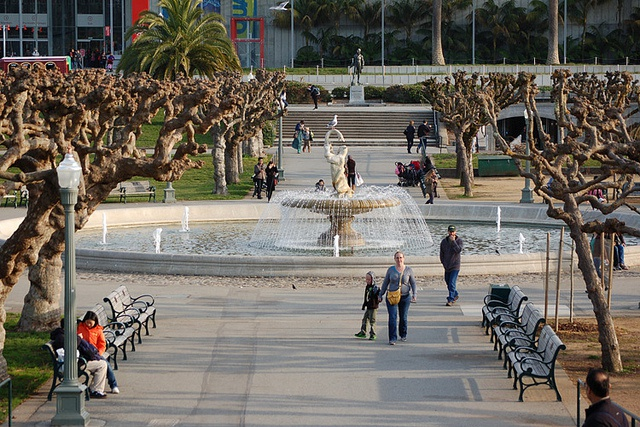Describe the objects in this image and their specific colors. I can see people in black, gray, maroon, and darkgray tones, bench in black, gray, and darkgray tones, people in black, gray, darkgray, and navy tones, bench in black, gray, and darkgray tones, and people in black, darkgray, gray, and navy tones in this image. 